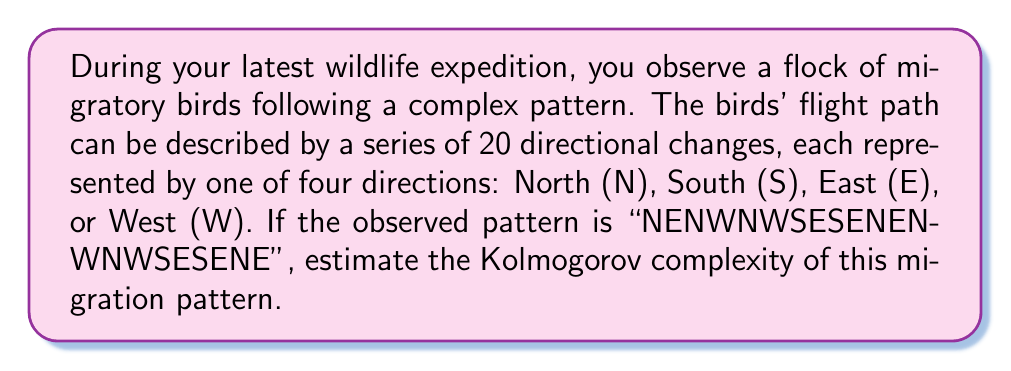Help me with this question. To estimate the Kolmogorov complexity of the given migration pattern, we need to consider the shortest possible program that could generate this sequence. Let's approach this step-by-step:

1) First, let's analyze the given sequence: NENWNWSESENENWNWSESENE

2) We can observe that there's no obvious simple repetition in the sequence.

3) One way to represent this sequence would be to simply list out all 20 directions. This would require 20 * 2 = 40 bits (assuming we use 2 bits to represent each of the four directions: 00 for N, 01 for E, 10 for S, 11 for W).

4) However, we can potentially compress this slightly by using a frequency table and Huffman coding:

   N: 6 times
   E: 6 times
   S: 3 times
   W: 5 times

5) Using Huffman coding, we might assign:
   N: 0
   E: 10
   W: 110
   S: 111

6) The encoded sequence would then be:
   0100110011111010111010010000110011111010

7) This encoded sequence is 38 bits long. We also need to store the Huffman tree, which requires additional bits.

8) The Huffman tree could be represented in about 16 bits (4 bits for each of the 4 symbols).

9) So, our total compressed representation would be about 38 + 16 = 54 bits.

10) Given that this is a relatively short sequence with no obvious patterns, this level of compression is likely close to the best we can achieve.

Therefore, we can estimate the Kolmogorov complexity of this migration pattern to be approximately 54 bits.

It's worth noting that this is an upper bound estimate. The true Kolmogorov complexity could be lower if there exists a more efficient algorithm to generate this sequence that we haven't discovered.
Answer: The estimated Kolmogorov complexity of the given migration pattern is approximately 54 bits. 